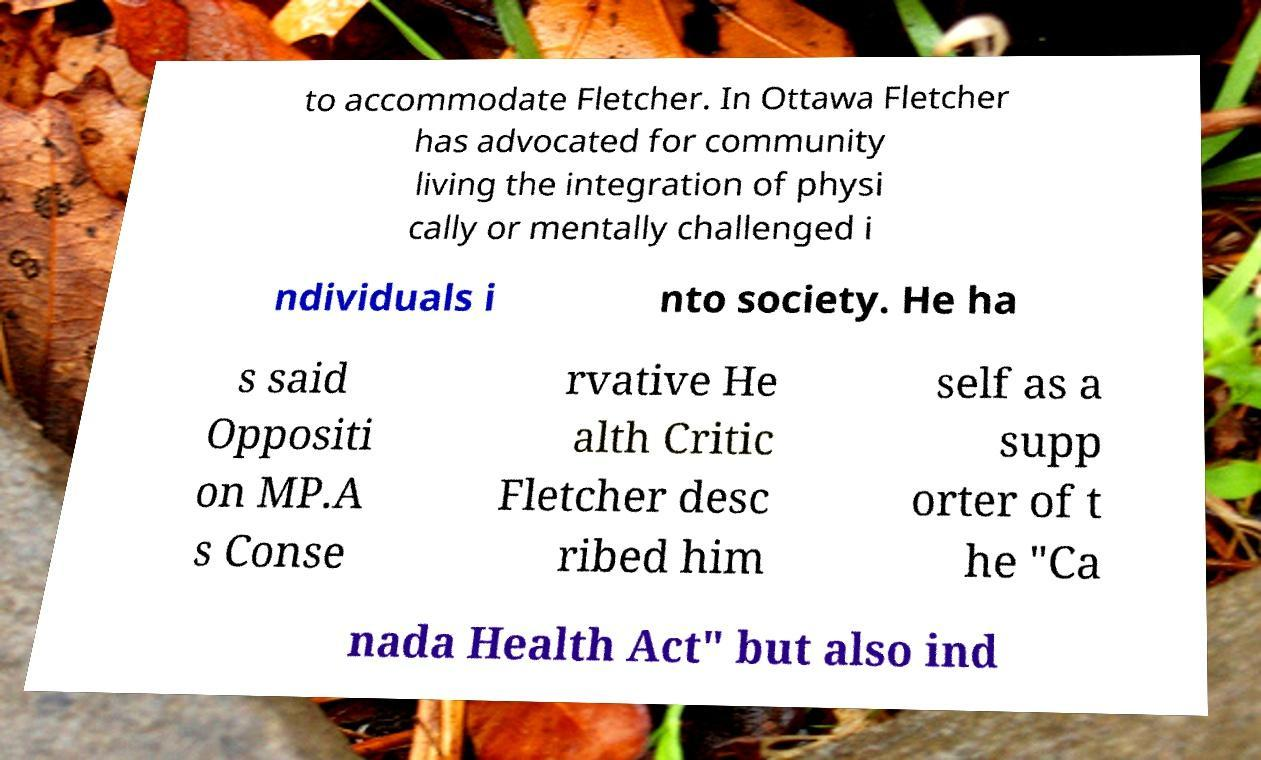Can you read and provide the text displayed in the image?This photo seems to have some interesting text. Can you extract and type it out for me? to accommodate Fletcher. In Ottawa Fletcher has advocated for community living the integration of physi cally or mentally challenged i ndividuals i nto society. He ha s said Oppositi on MP.A s Conse rvative He alth Critic Fletcher desc ribed him self as a supp orter of t he "Ca nada Health Act" but also ind 